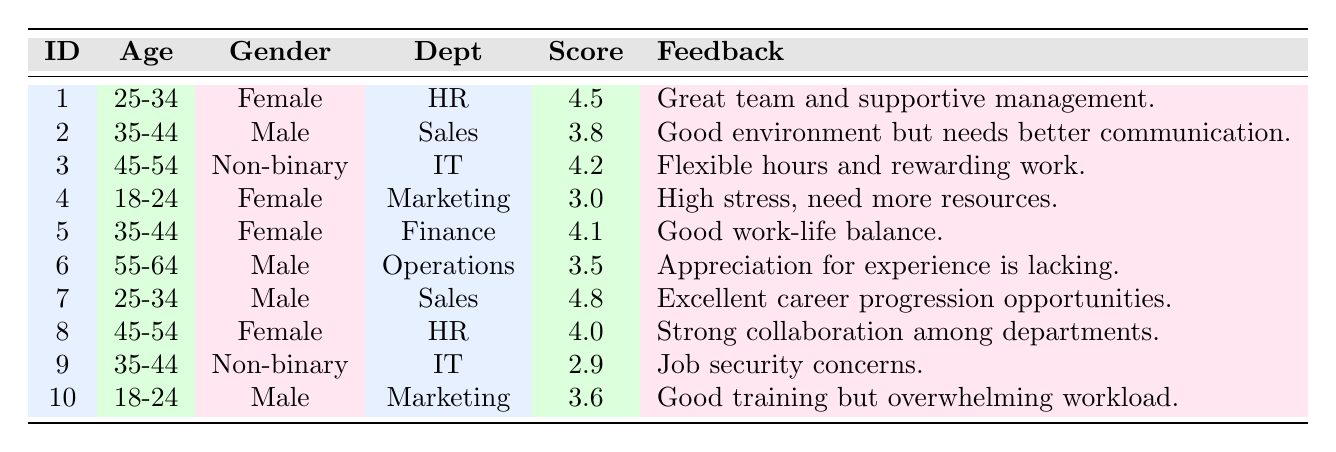What is the satisfaction score of the employee in the HR department? The employee in the HR department is Employee ID 1, and their satisfaction score is listed as 4.5.
Answer: 4.5 How many employees reported a satisfaction score of 3.0 or higher? By checking the satisfaction scores listed, we find that the employees with scores of 3.0 or higher are Employee IDs 1, 2, 3, 5, 6, 7, 8, and 10, totaling 8 employees.
Answer: 8 Is there any employee who rated their satisfaction score below 3.0? Employee ID 4 rated their satisfaction score as 3.0, but Employee ID 9 rated theirs at 2.9, which is below 3.0.
Answer: Yes What is the average satisfaction score for female employees? The female employees have the following scores: 4.5 (Employee 1), 4.1 (Employee 5), 3.0 (Employee 4), and 4.0 (Employee 8). Adding these scores gives us 4.5 + 4.1 + 3.0 + 4.0 = 15.6. Dividing by the number of female employees (4) gives us 15.6 / 4 = 3.9.
Answer: 3.9 Which age group has the highest individual satisfaction score? The employee from the age group 25-34 (Employee 7) has the highest individual score, which is 4.8. Other age groups have lower individual scores such as 4.5 (25-34, Employee 1) and 4.2 (45-54, Employee 3).
Answer: 25-34 What percentage of employees working in Marketing rated their satisfaction scores? The table shows 2 employees in the Marketing department (Employee IDs 4 and 10). Both rated their satisfaction scores, thus 2 out of 10 total employees have ratings in this department. This leads to 2 / 10 * 100 = 20%.
Answer: 20% How many non-binary employees provided feedback and what was their average satisfaction score? There are two non-binary employees: Employee 3 with a score of 4.2 and Employee 9 with a score of 2.9. Adding these scores gives 4.2 + 2.9 = 7.1; dividing by the number of non-binary employees (2) results in an average score of 7.1 / 2 = 3.55.
Answer: 3.55 Do male employees have a higher average satisfaction score than female employees? The male employees (Employee 2: 3.8, Employee 6: 3.5, Employee 7: 4.8) have an average score of (3.8 + 3.5 + 4.8) / 3 = 4.03. The female employees have an average score of 3.9 as calculated previously. Comparing 4.03 to 3.9 shows that male employees do have a higher average satisfaction score.
Answer: Yes 